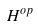Convert formula to latex. <formula><loc_0><loc_0><loc_500><loc_500>H ^ { o p }</formula> 